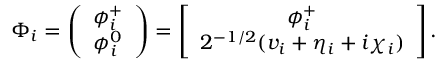Convert formula to latex. <formula><loc_0><loc_0><loc_500><loc_500>\Phi _ { i } = \left ( \begin{array} { c } { { \phi _ { i } ^ { + } } } \\ { { \phi _ { i } ^ { 0 } } } \end{array} \right ) = \left [ \begin{array} { c } { { \phi _ { i } ^ { + } } } \\ { { 2 ^ { - 1 / 2 } ( v _ { i } + \eta _ { i } + i \chi _ { i } ) } } \end{array} \right ] .</formula> 